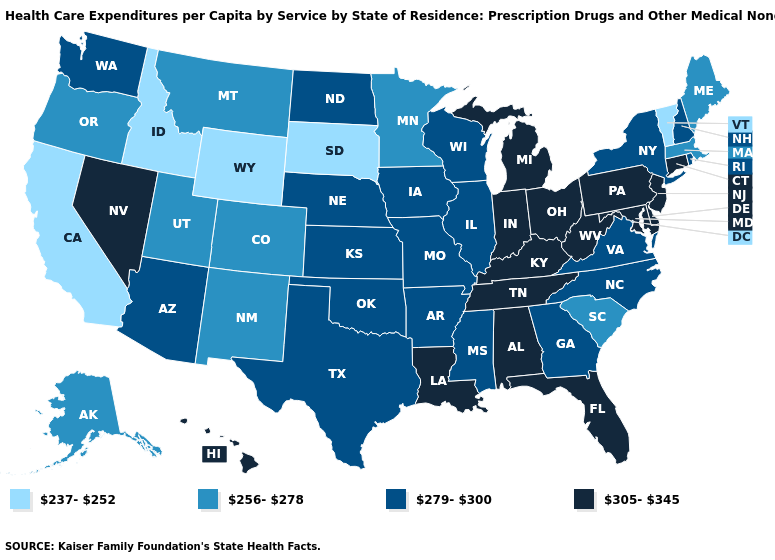Name the states that have a value in the range 279-300?
Answer briefly. Arizona, Arkansas, Georgia, Illinois, Iowa, Kansas, Mississippi, Missouri, Nebraska, New Hampshire, New York, North Carolina, North Dakota, Oklahoma, Rhode Island, Texas, Virginia, Washington, Wisconsin. Name the states that have a value in the range 279-300?
Answer briefly. Arizona, Arkansas, Georgia, Illinois, Iowa, Kansas, Mississippi, Missouri, Nebraska, New Hampshire, New York, North Carolina, North Dakota, Oklahoma, Rhode Island, Texas, Virginia, Washington, Wisconsin. Does the first symbol in the legend represent the smallest category?
Keep it brief. Yes. Among the states that border Missouri , which have the highest value?
Write a very short answer. Kentucky, Tennessee. Does the map have missing data?
Quick response, please. No. Does Alaska have the lowest value in the USA?
Give a very brief answer. No. Does New Jersey have the highest value in the USA?
Write a very short answer. Yes. Does the map have missing data?
Be succinct. No. Does Kansas have the lowest value in the MidWest?
Quick response, please. No. What is the value of Maryland?
Keep it brief. 305-345. Name the states that have a value in the range 237-252?
Keep it brief. California, Idaho, South Dakota, Vermont, Wyoming. Name the states that have a value in the range 279-300?
Give a very brief answer. Arizona, Arkansas, Georgia, Illinois, Iowa, Kansas, Mississippi, Missouri, Nebraska, New Hampshire, New York, North Carolina, North Dakota, Oklahoma, Rhode Island, Texas, Virginia, Washington, Wisconsin. Name the states that have a value in the range 279-300?
Give a very brief answer. Arizona, Arkansas, Georgia, Illinois, Iowa, Kansas, Mississippi, Missouri, Nebraska, New Hampshire, New York, North Carolina, North Dakota, Oklahoma, Rhode Island, Texas, Virginia, Washington, Wisconsin. Does the first symbol in the legend represent the smallest category?
Answer briefly. Yes. What is the lowest value in the USA?
Short answer required. 237-252. 